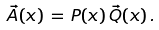<formula> <loc_0><loc_0><loc_500><loc_500>\vec { \mathsf A } ( x ) \, = \, P ( x ) \, \vec { \mathsf Q } ( x ) \, .</formula> 